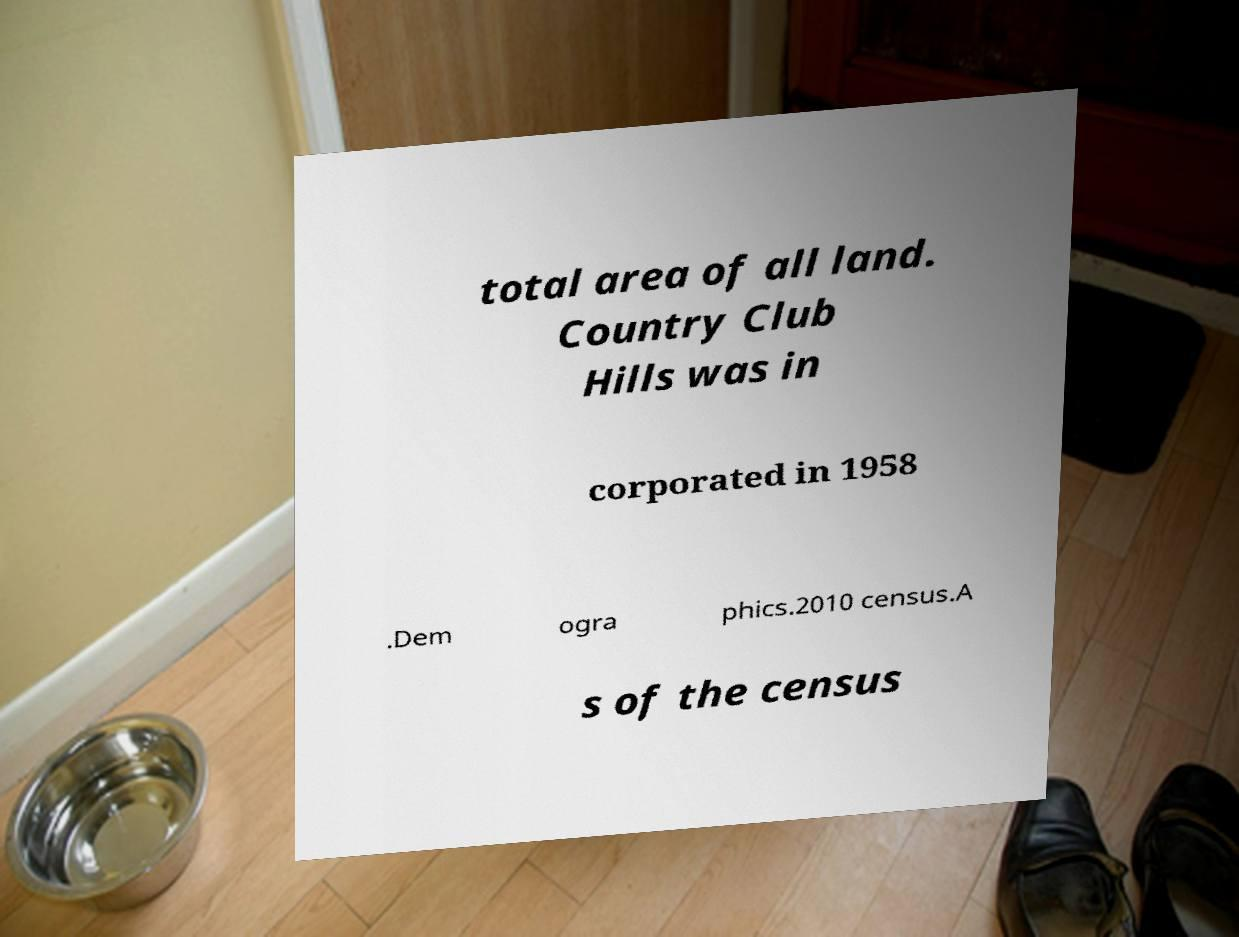For documentation purposes, I need the text within this image transcribed. Could you provide that? total area of all land. Country Club Hills was in corporated in 1958 .Dem ogra phics.2010 census.A s of the census 